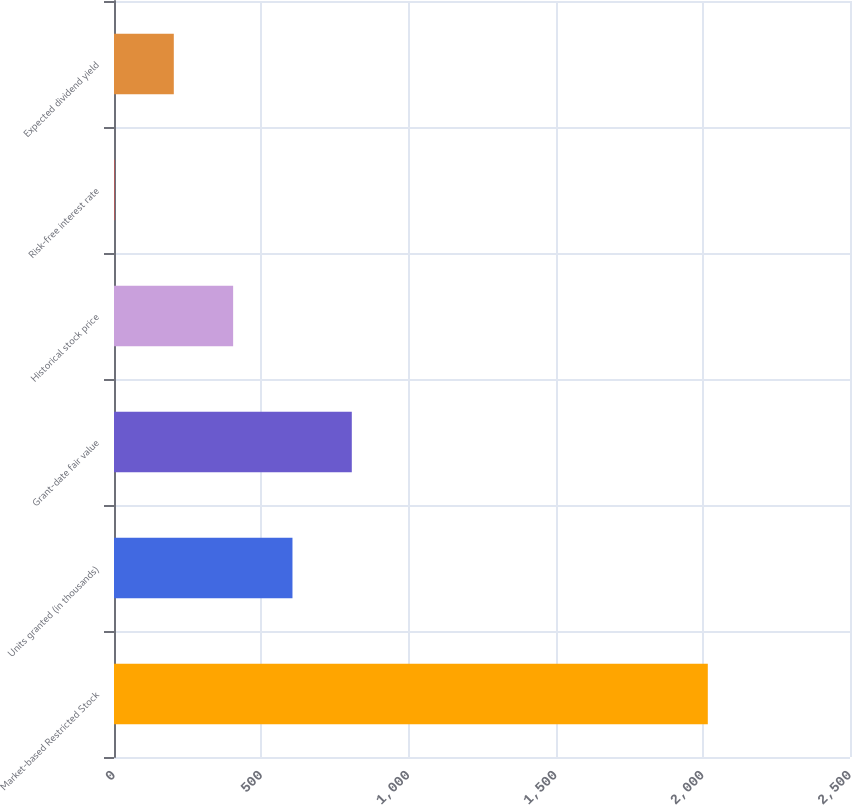<chart> <loc_0><loc_0><loc_500><loc_500><bar_chart><fcel>Market-based Restricted Stock<fcel>Units granted (in thousands)<fcel>Grant-date fair value<fcel>Historical stock price<fcel>Risk-free interest rate<fcel>Expected dividend yield<nl><fcel>2017<fcel>606.22<fcel>807.76<fcel>404.68<fcel>1.6<fcel>203.14<nl></chart> 